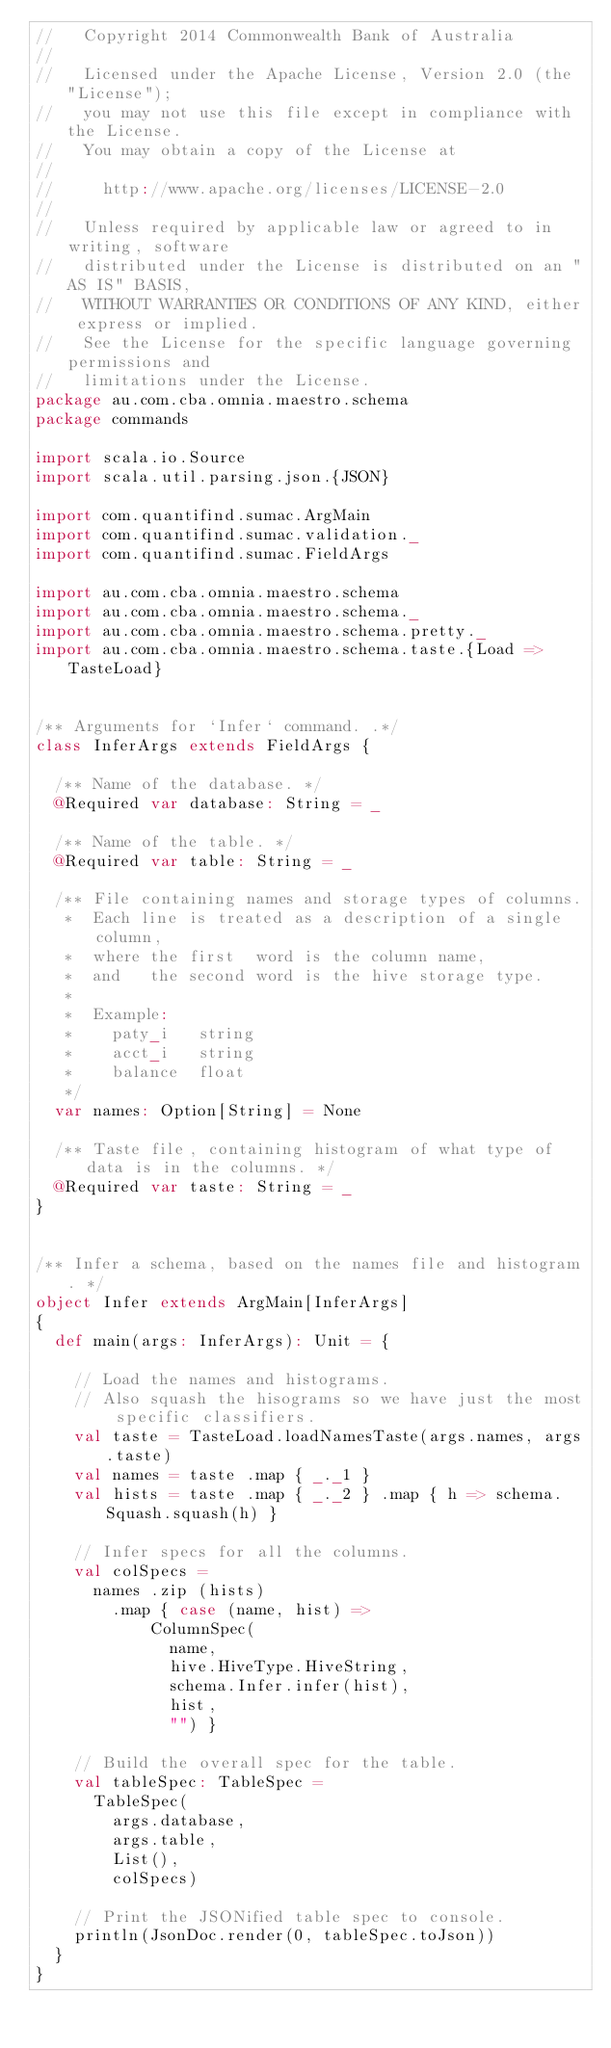Convert code to text. <code><loc_0><loc_0><loc_500><loc_500><_Scala_>//   Copyright 2014 Commonwealth Bank of Australia
//
//   Licensed under the Apache License, Version 2.0 (the "License");
//   you may not use this file except in compliance with the License.
//   You may obtain a copy of the License at
//
//     http://www.apache.org/licenses/LICENSE-2.0
//
//   Unless required by applicable law or agreed to in writing, software
//   distributed under the License is distributed on an "AS IS" BASIS,
//   WITHOUT WARRANTIES OR CONDITIONS OF ANY KIND, either express or implied.
//   See the License for the specific language governing permissions and
//   limitations under the License.
package au.com.cba.omnia.maestro.schema
package commands

import scala.io.Source
import scala.util.parsing.json.{JSON}

import com.quantifind.sumac.ArgMain
import com.quantifind.sumac.validation._
import com.quantifind.sumac.FieldArgs

import au.com.cba.omnia.maestro.schema
import au.com.cba.omnia.maestro.schema._
import au.com.cba.omnia.maestro.schema.pretty._
import au.com.cba.omnia.maestro.schema.taste.{Load => TasteLoad}


/** Arguments for `Infer` command. .*/
class InferArgs extends FieldArgs {

  /** Name of the database. */
  @Required var database: String = _

  /** Name of the table. */
  @Required var table: String = _

  /** File containing names and storage types of columns.
   *  Each line is treated as a description of a single column,
   *  where the first  word is the column name,
   *  and   the second word is the hive storage type.
   *
   *  Example:
   *    paty_i   string
   *    acct_i   string
   *    balance  float
   */
  var names: Option[String] = None

  /** Taste file, containing histogram of what type of data is in the columns. */
  @Required var taste: String = _
}


/** Infer a schema, based on the names file and histogram. */
object Infer extends ArgMain[InferArgs]
{
  def main(args: InferArgs): Unit = {

    // Load the names and histograms.
    // Also squash the hisograms so we have just the most specific classifiers.
    val taste = TasteLoad.loadNamesTaste(args.names, args.taste)
    val names = taste .map { _._1 }
    val hists = taste .map { _._2 } .map { h => schema.Squash.squash(h) }

    // Infer specs for all the columns.
    val colSpecs =
      names .zip (hists)
        .map { case (name, hist) =>
            ColumnSpec(
              name,
              hive.HiveType.HiveString,
              schema.Infer.infer(hist),
              hist,
              "") }

    // Build the overall spec for the table.
    val tableSpec: TableSpec =
      TableSpec(
        args.database,
        args.table,
        List(),
        colSpecs)

    // Print the JSONified table spec to console.
    println(JsonDoc.render(0, tableSpec.toJson))
  }
}
</code> 